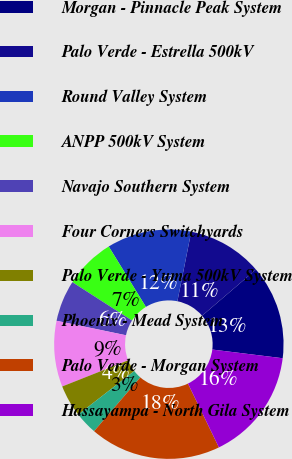Convert chart to OTSL. <chart><loc_0><loc_0><loc_500><loc_500><pie_chart><fcel>Morgan - Pinnacle Peak System<fcel>Palo Verde - Estrella 500kV<fcel>Round Valley System<fcel>ANPP 500kV System<fcel>Navajo Southern System<fcel>Four Corners Switchyards<fcel>Palo Verde - Yuma 500kV System<fcel>Phoenix - Mead System<fcel>Palo Verde - Morgan System<fcel>Hassayampa - North Gila System<nl><fcel>13.23%<fcel>10.6%<fcel>11.91%<fcel>7.13%<fcel>5.82%<fcel>9.28%<fcel>4.5%<fcel>3.19%<fcel>18.49%<fcel>15.86%<nl></chart> 